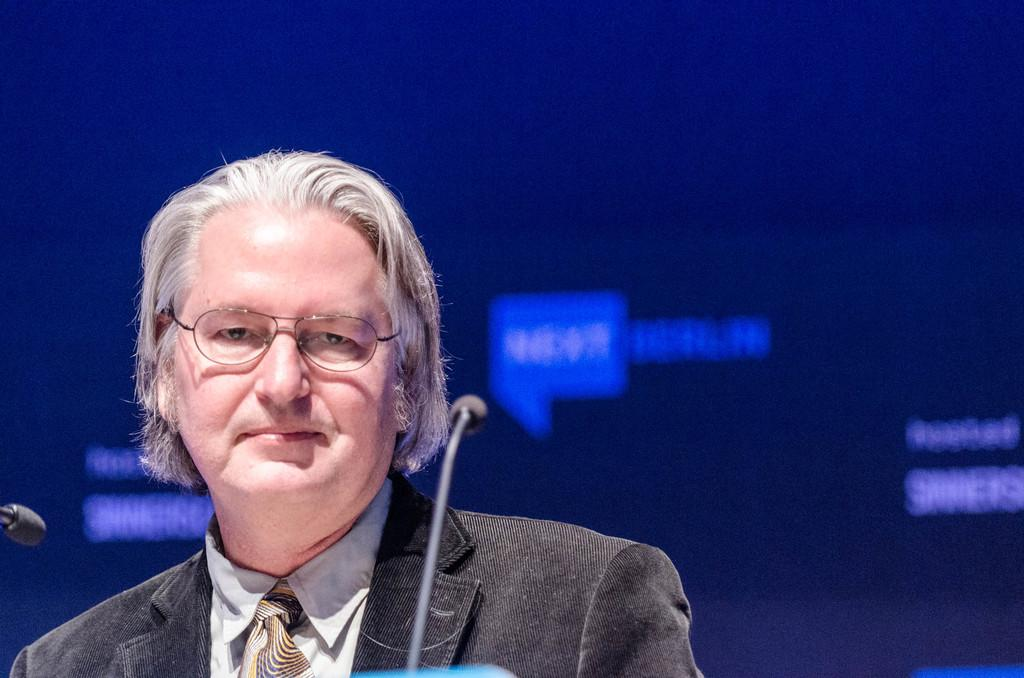What is the person in the image wearing? The person in the image is wearing a suit. What is the facial expression of the person in the image? The person is smiling. What accessory is the person wearing? The person is wearing glasses. What equipment is present in the image? There are microphones in the image. What can be seen in the background of the image? There is a screen in the background of the image. What symbols or images are visible in the image? There are icons visible in the image. What type of competition is the person participating in during dinner? There is no competition or dinner present in the image; it only features a person in a suit, wearing glasses and smiling, with microphones, a screen, and icons visible. 